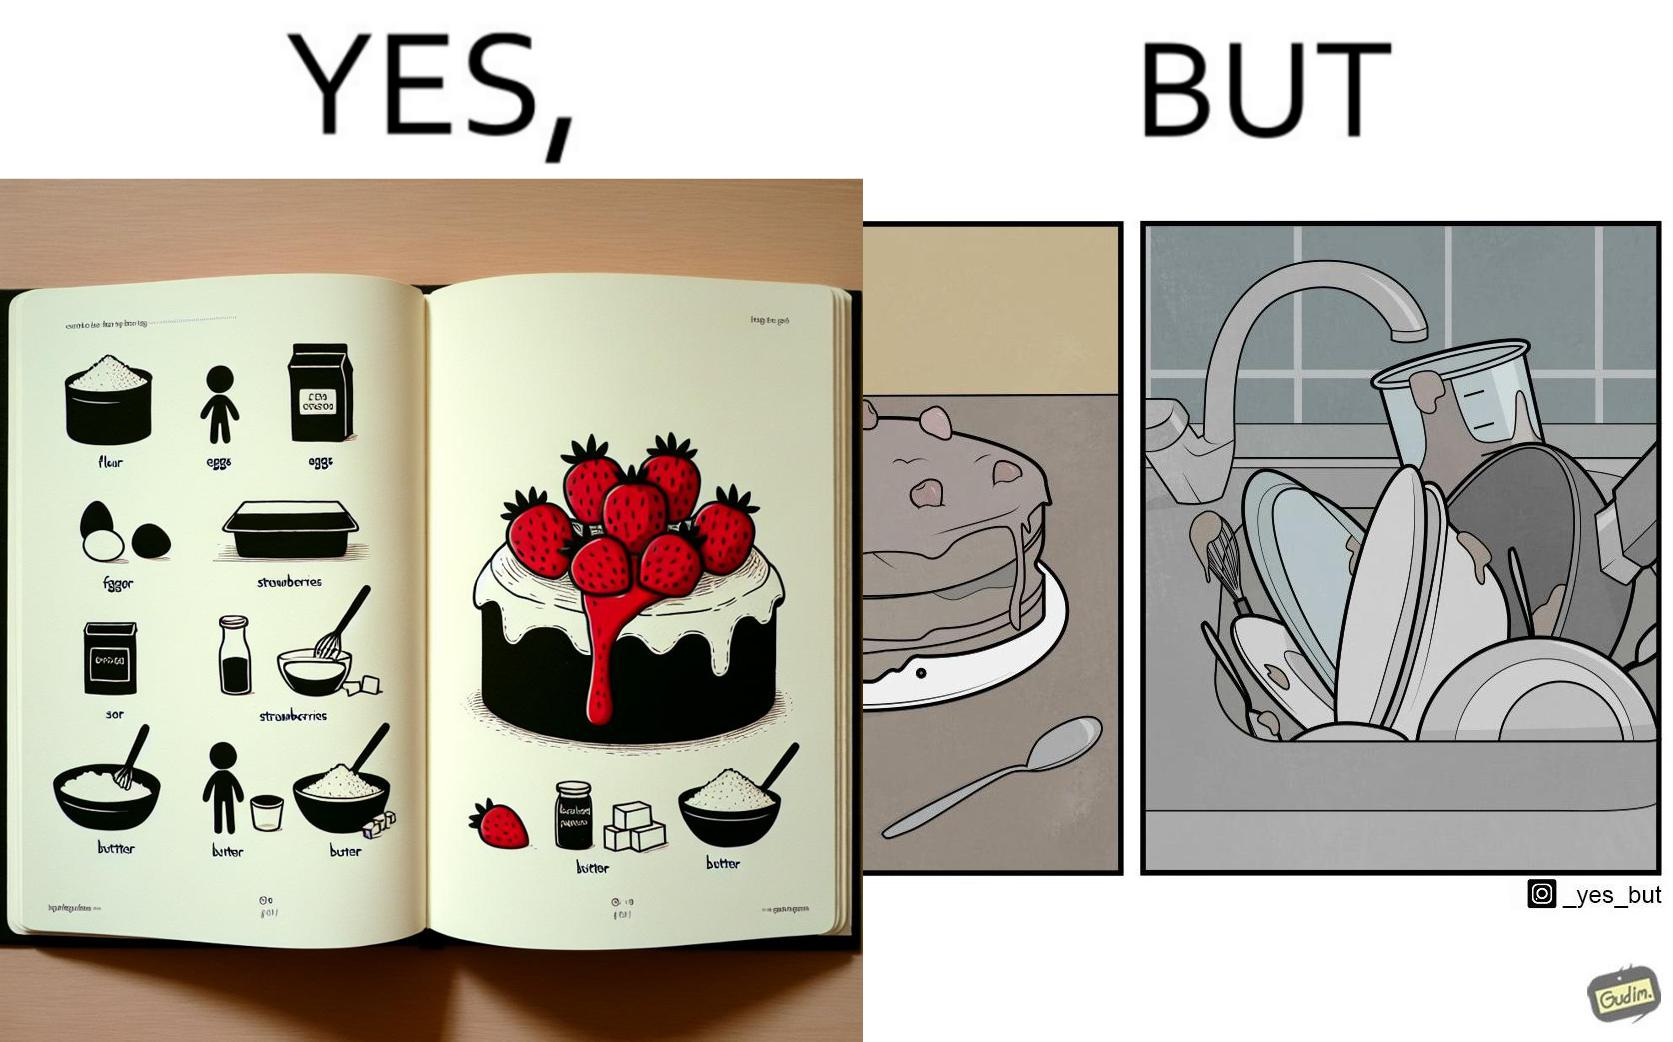Is this a satirical image? Yes, this image is satirical. 